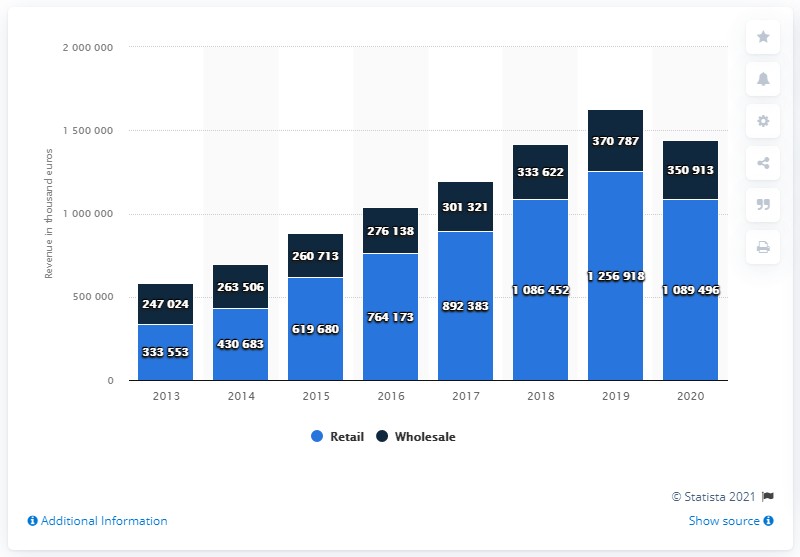Mention a couple of crucial points in this snapshot. The highest value of navy blue bar recorded over the years is 370787. In the year 2019, the difference between the revenues of retail and wholesale was at its maximum. 